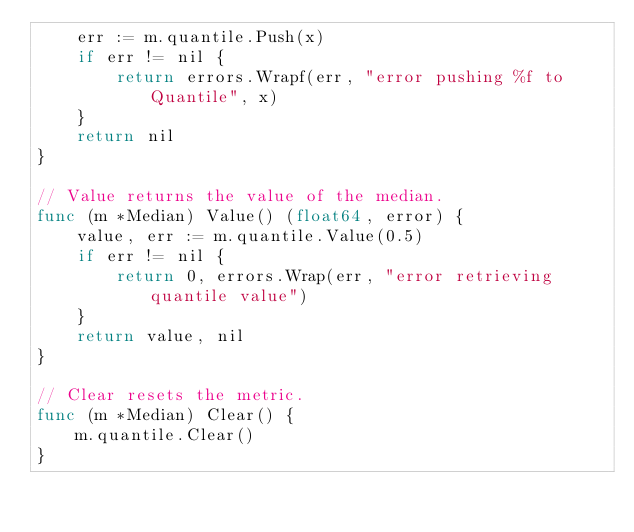Convert code to text. <code><loc_0><loc_0><loc_500><loc_500><_Go_>	err := m.quantile.Push(x)
	if err != nil {
		return errors.Wrapf(err, "error pushing %f to Quantile", x)
	}
	return nil
}

// Value returns the value of the median.
func (m *Median) Value() (float64, error) {
	value, err := m.quantile.Value(0.5)
	if err != nil {
		return 0, errors.Wrap(err, "error retrieving quantile value")
	}
	return value, nil
}

// Clear resets the metric.
func (m *Median) Clear() {
	m.quantile.Clear()
}
</code> 